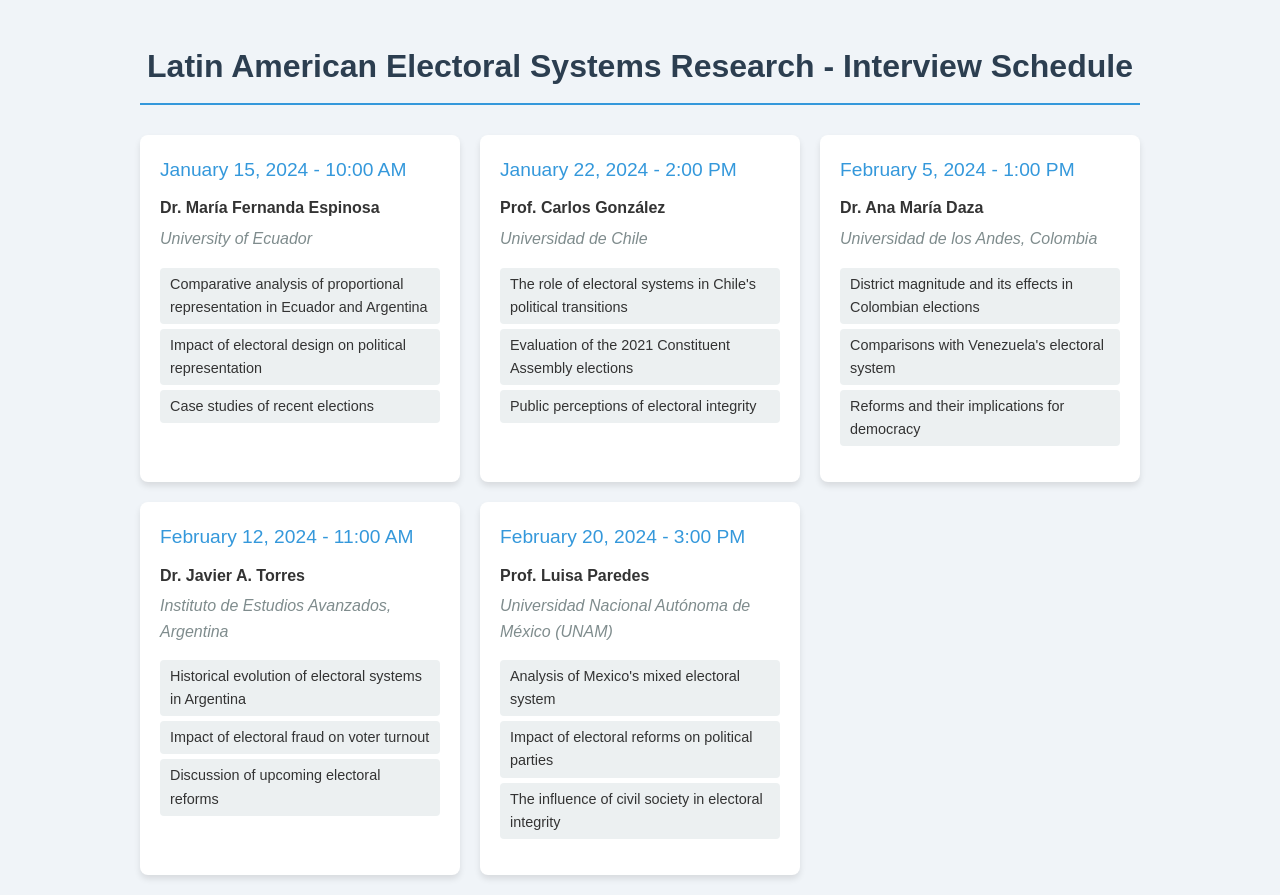What is the name of the first expert? The first expert's name is listed at the top of the first interview card in the document.
Answer: Dr. María Fernanda Espinosa When is the interview with Prof. Carlos González scheduled? The date and time for Prof. Carlos González's interview is clearly stated on his interview card.
Answer: January 22, 2024 - 2:00 PM Which university is Dr. Ana María Daza affiliated with? The expert's affiliation is presented under her name in her interview card.
Answer: Universidad de los Andes, Colombia What is one topic discussed in Dr. Javier A. Torres's interview? The topics discussed are listed in bullet points on his interview card.
Answer: Historical evolution of electoral systems in Argentina How many interview dates are mentioned in the schedule? The number of interviews can be counted from the total number of interview cards present in the document.
Answer: Five What aspect of electoral systems does Prof. Luisa Paredes focus on? This information is found under her name in her interview card and reflects her areas of expertise.
Answer: Analysis of Mexico's mixed electoral system Which interview is scheduled for February 20, 2024? The specific date corresponds to the details stated on the interview card.
Answer: Prof. Luisa Paredes What is the common theme among the experts' discussions? By analyzing the topics mentioned, one can see the overarching theme regarding electoral systems in Latin America.
Answer: Electoral systems and reforms 